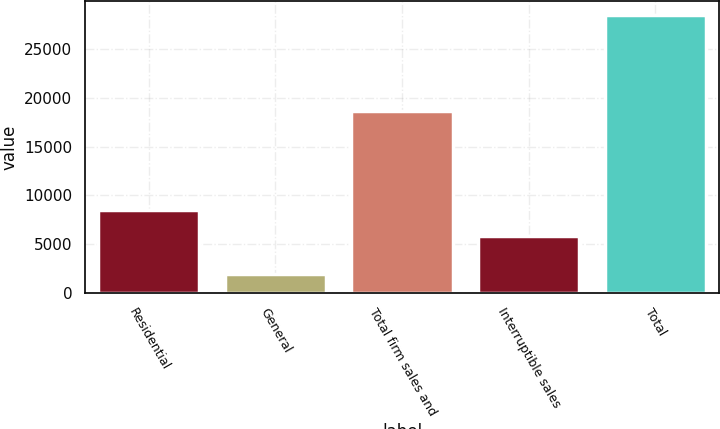Convert chart. <chart><loc_0><loc_0><loc_500><loc_500><bar_chart><fcel>Residential<fcel>General<fcel>Total firm sales and<fcel>Interruptible sales<fcel>Total<nl><fcel>8520.7<fcel>1892<fcel>18708<fcel>5856<fcel>28539<nl></chart> 